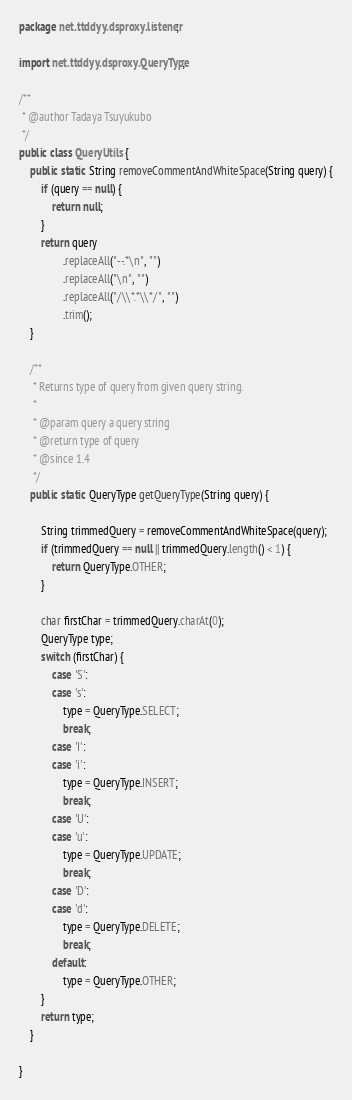<code> <loc_0><loc_0><loc_500><loc_500><_Java_>package net.ttddyy.dsproxy.listener;

import net.ttddyy.dsproxy.QueryType;

/**
 * @author Tadaya Tsuyukubo
 */
public class QueryUtils {
    public static String removeCommentAndWhiteSpace(String query) {
        if (query == null) {
            return null;
        }
        return query
                .replaceAll("--.*\n", "")
                .replaceAll("\n", "")
                .replaceAll("/\\*.*\\*/", "")
                .trim();
    }

    /**
     * Returns type of query from given query string.
     *
     * @param query a query string
     * @return type of query
     * @since 1.4
     */
    public static QueryType getQueryType(String query) {

        String trimmedQuery = removeCommentAndWhiteSpace(query);
        if (trimmedQuery == null || trimmedQuery.length() < 1) {
            return QueryType.OTHER;
        }

        char firstChar = trimmedQuery.charAt(0);
        QueryType type;
        switch (firstChar) {
            case 'S':
            case 's':
                type = QueryType.SELECT;
                break;
            case 'I':
            case 'i':
                type = QueryType.INSERT;
                break;
            case 'U':
            case 'u':
                type = QueryType.UPDATE;
                break;
            case 'D':
            case 'd':
                type = QueryType.DELETE;
                break;
            default:
                type = QueryType.OTHER;
        }
        return type;
    }

}
</code> 